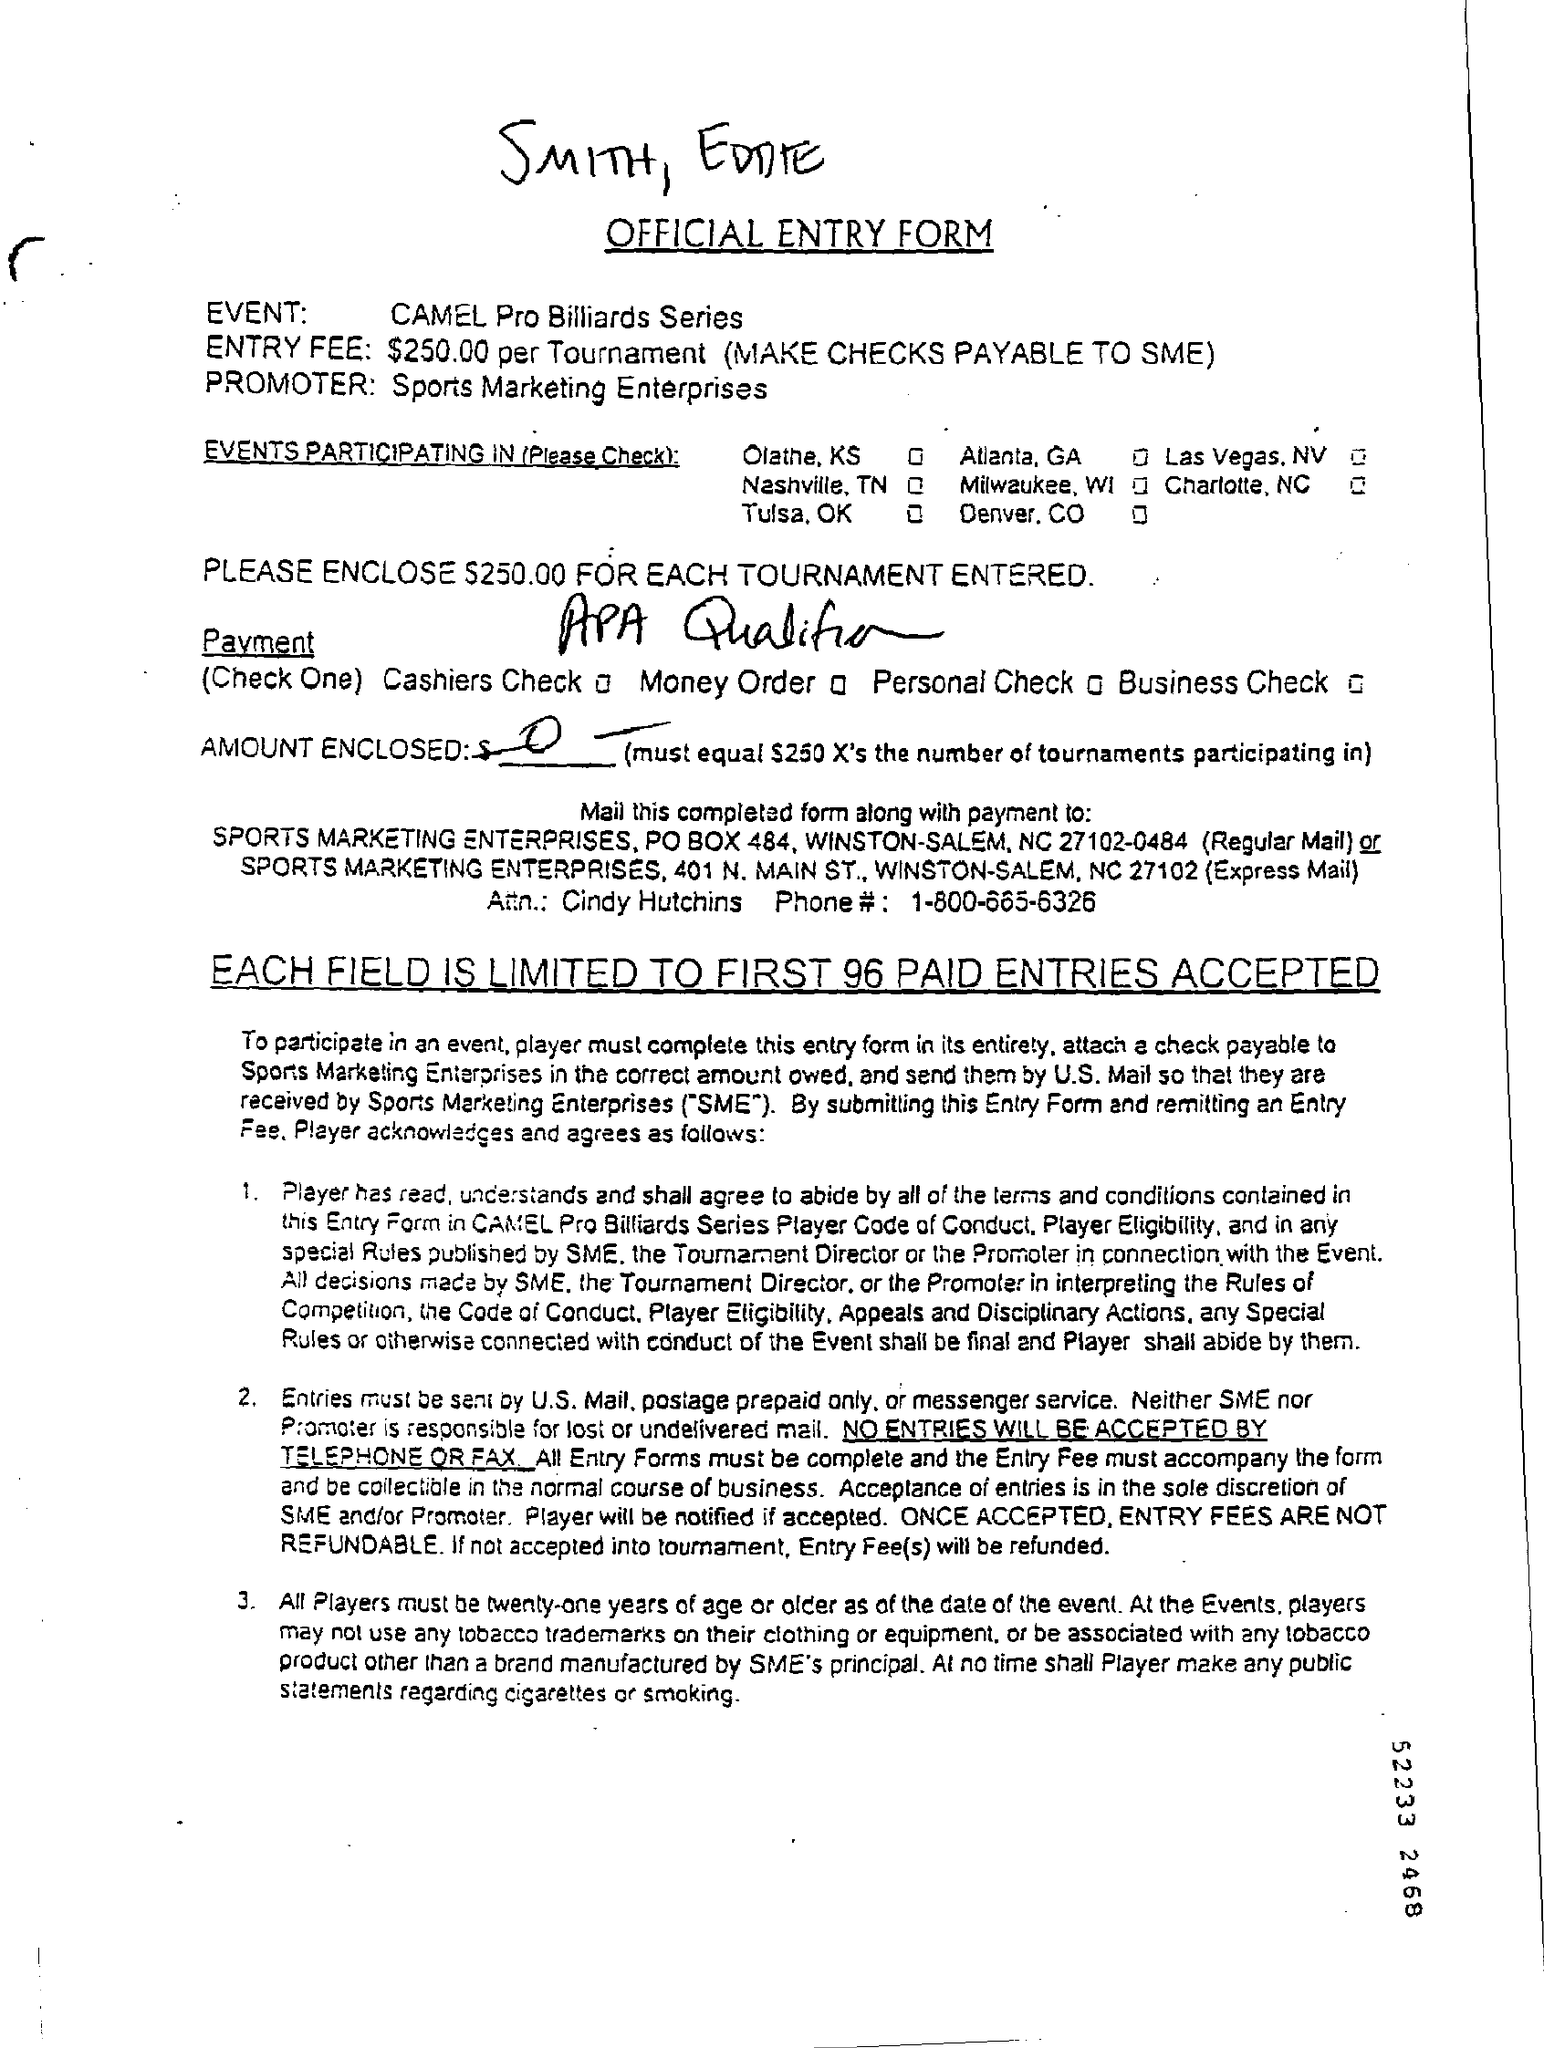WHAT IS THE NAME OF THE EVENT ?
Offer a terse response. Camel pro billiards series. What is the entry fee mentioned in the official entry form ?
Offer a very short reply. $ 250.00 per tournament. What is the name of the promoter mentioned in the official entry form ?
Your response must be concise. Sports marketing enterprises. What is the phone number mentioned in the form ?
Your response must be concise. 1-800-665-6326. What is the full form of sme ?
Provide a succinct answer. Sports Marketing Enterprises. 